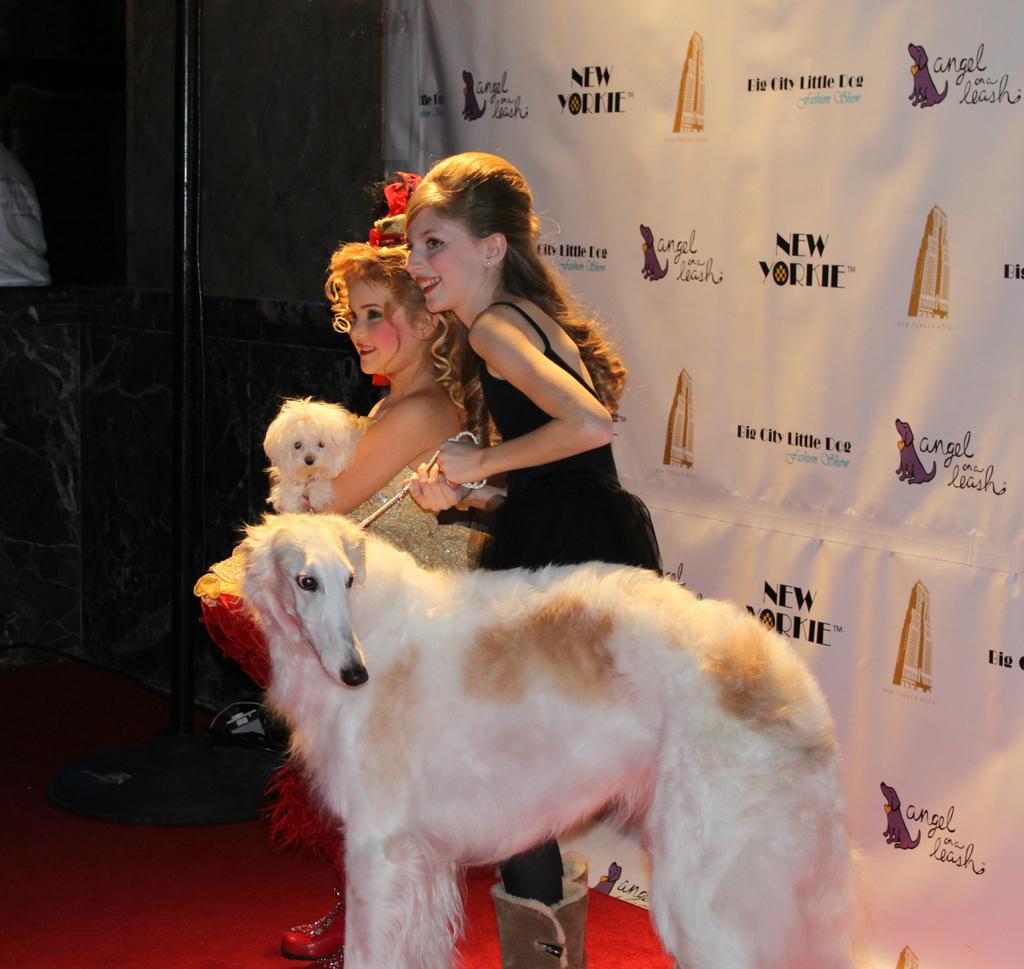How many people are in the image? There are two girls in the image. What are the girls doing in the image? The girls are standing and holding two dogs. What is the emotional expression of the girls in the image? The girls are smiling in the image. What can be seen in the background of the image? There is a poster in the background of the image. What type of competition is the girls participating in with their dogs in the image? There is no competition present in the image; the girls are simply standing and holding their dogs. Can you see any beetles in the image? There are no beetles present in the image. 